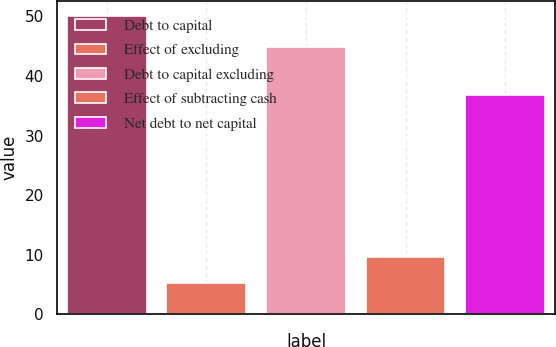Convert chart. <chart><loc_0><loc_0><loc_500><loc_500><bar_chart><fcel>Debt to capital<fcel>Effect of excluding<fcel>Debt to capital excluding<fcel>Effect of subtracting cash<fcel>Net debt to net capital<nl><fcel>50.1<fcel>5.2<fcel>44.9<fcel>9.69<fcel>36.9<nl></chart> 